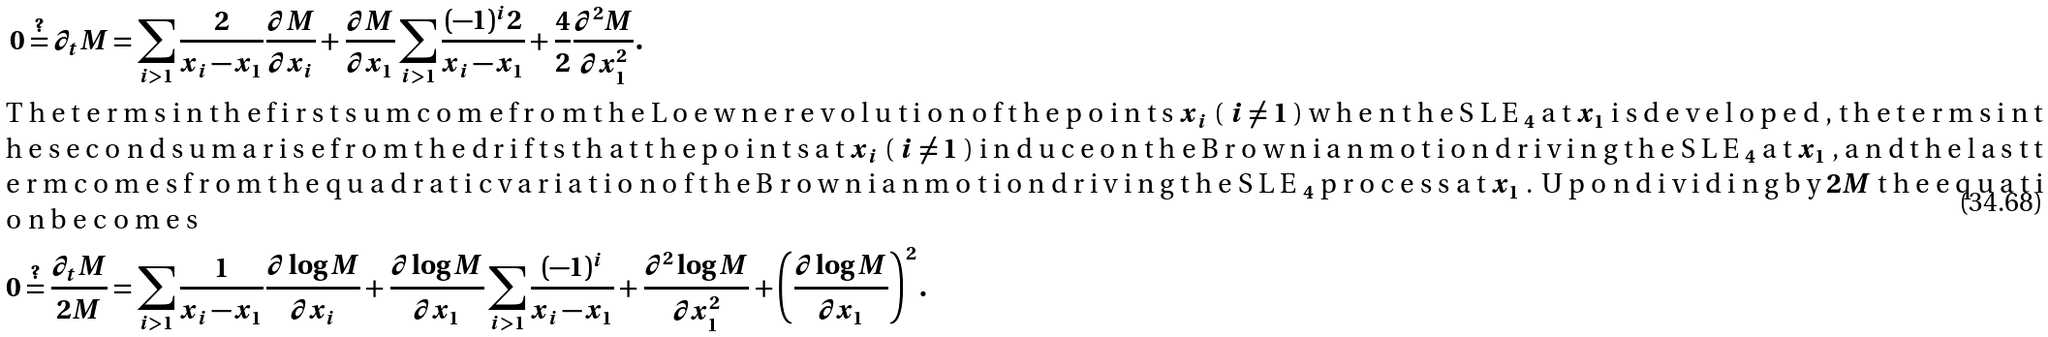Convert formula to latex. <formula><loc_0><loc_0><loc_500><loc_500>0 \stackrel { ? } { = } \partial _ { t } M & = \sum _ { i > 1 } \frac { 2 } { x _ { i } - x _ { 1 } } \frac { \partial M } { \partial x _ { i } } + \frac { \partial M } { \partial x _ { 1 } } \sum _ { i > 1 } \frac { ( - 1 ) ^ { i } 2 } { x _ { i } - x _ { 1 } } + \frac { 4 } { 2 } \frac { \partial ^ { 2 } M } { \partial x _ { 1 } ^ { 2 } } . \\ \intertext { T h e t e r m s i n t h e f i r s t s u m c o m e f r o m t h e L o e w n e r e v o l u t i o n o f t h e p o i n t s $ x _ { i } $ ( $ i \neq 1 $ ) w h e n t h e S L E $ _ { 4 } $ a t $ x _ { 1 } $ i s d e v e l o p e d , t h e t e r m s i n t h e s e c o n d s u m a r i s e f r o m t h e d r i f t s t h a t t h e p o i n t s a t $ x _ { i } $ ( $ i \neq 1 $ ) i n d u c e o n t h e B r o w n i a n m o t i o n d r i v i n g t h e S L E $ _ { 4 } $ a t $ x _ { 1 } $ , a n d t h e l a s t t e r m c o m e s f r o m t h e q u a d r a t i c v a r i a t i o n o f t h e B r o w n i a n m o t i o n d r i v i n g t h e S L E $ _ { 4 } $ p r o c e s s a t $ x _ { 1 } $ . U p o n d i v i d i n g b y $ 2 M $ t h e e q u a t i o n b e c o m e s } 0 \stackrel { ? } { = } \frac { \partial _ { t } M } { 2 M } & = \sum _ { i > 1 } \frac { 1 } { x _ { i } - x _ { 1 } } \frac { \partial \log M } { \partial x _ { i } } + \frac { \partial \log M } { \partial x _ { 1 } } \sum _ { i > 1 } \frac { ( - 1 ) ^ { i } } { x _ { i } - x _ { 1 } } + \frac { \partial ^ { 2 } \log M } { \partial x _ { 1 } ^ { 2 } } + \left ( \frac { \partial \log M } { \partial x _ { 1 } } \right ) ^ { 2 } .</formula> 